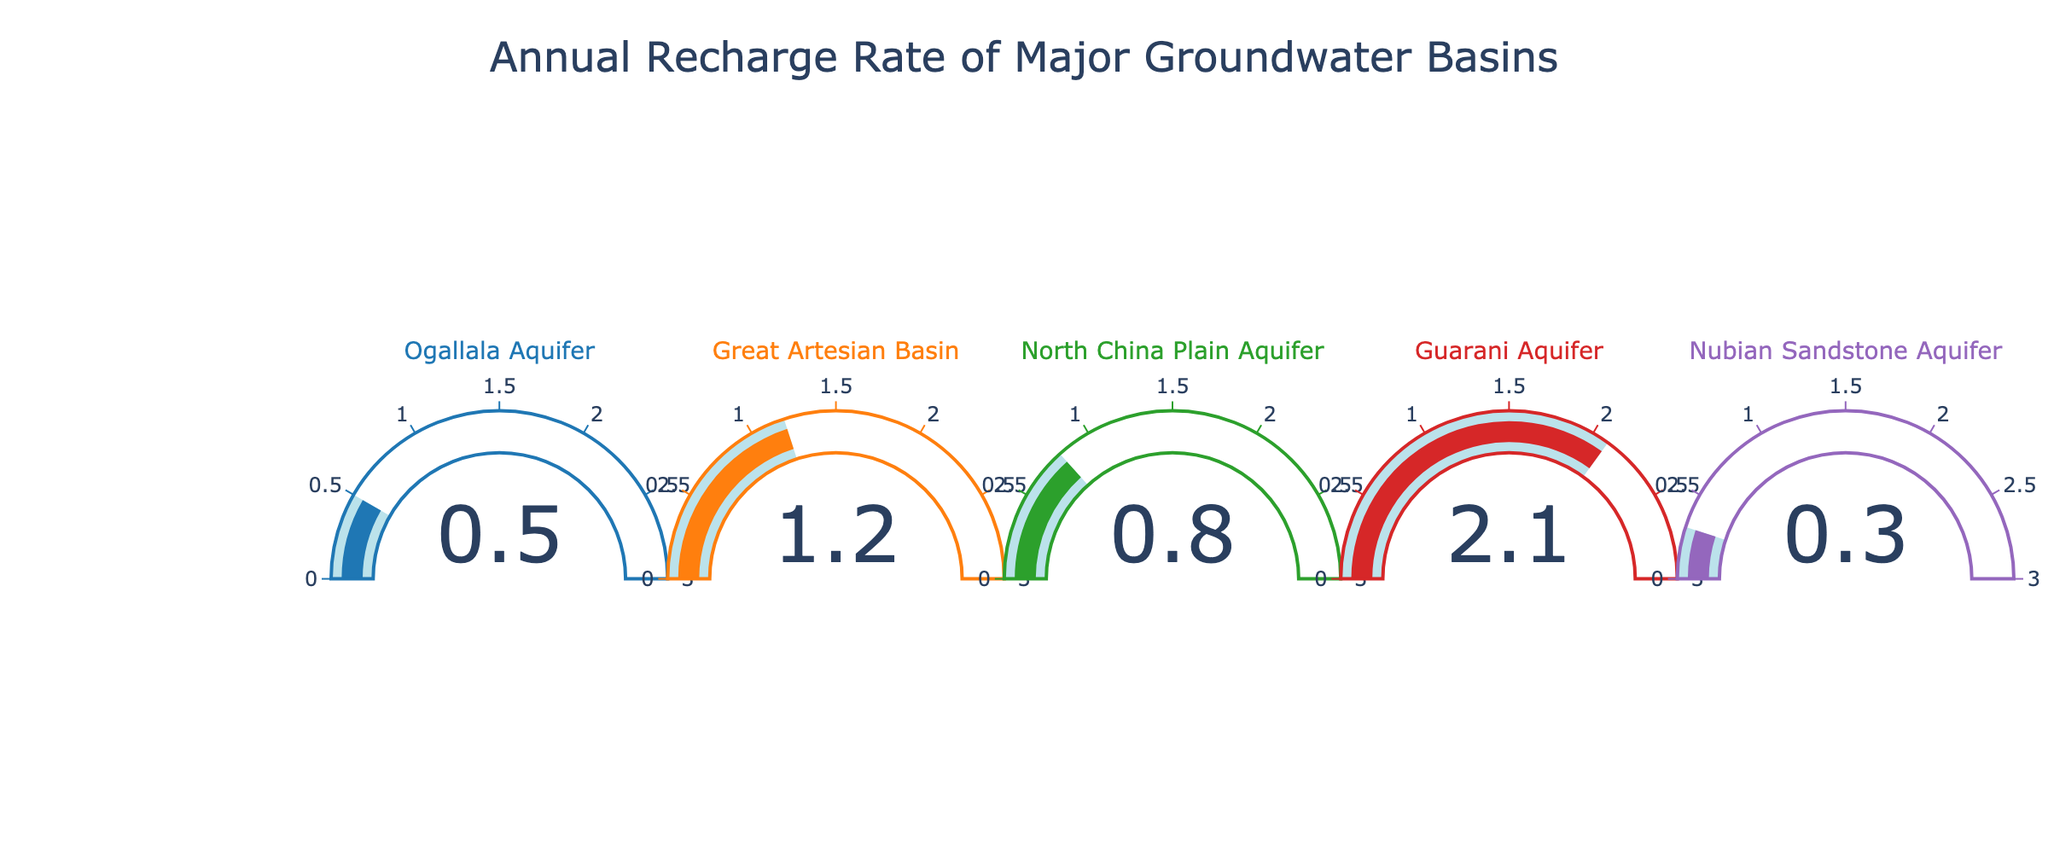what is the title of the figure? The title of the figure is usually presented at the top of the chart. By looking at the top center, we can see the title.
Answer: Annual Recharge Rate of Major Groundwater Basins How many groundwater basins are represented in the chart? By counting the number of individual gauges on the chart, each representing a basin, you can determine the total number.
Answer: 5 Which groundwater basin has the highest annual recharge rate? Observe the value indicated by each gauge. The one with the highest number represents the highest recharge rate.
Answer: Guarani Aquifer What is the range of values on the gauge axis? The gauge axis range is often indicated along the semi-circle of the gauge. One can observe the minimum and maximum values noted on the axis.
Answer: 0 to 3 What is the average annual recharge rate of all the basins? Sum the recharge rates of all basins (0.5 + 1.2 + 0.8 + 2.1 + 0.3) and divide by the number of basins (5). The calculation will give the average value.
Answer: 0.98 Which basin has the lowest annual recharge rate? Look at the values displayed in each gauge. The one with the smallest number will be the lowest.
Answer: Nubian Sandstone Aquifer What is the difference in the annual recharge rate between the Guarani Aquifer and the Great Artesian Basin? Subtract the annual recharge rate of the Great Artesian Basin (1.2) from that of the Guarani Aquifer (2.1).
Answer: 0.9 What is the combined annual recharge rate of the Ogallala Aquifer and the North China Plain Aquifer? Add the individual annual recharge rates of the Ogallala Aquifer (0.5) and the North China Plain Aquifer (0.8).
Answer: 1.3 Which color represents the Great Artesian Basin? The color indicated in the gauge decoration and title for the Great Artesian Basin corresponds to the associated value.
Answer: Orange (usually, but the exact color would be derived from the chart specifics) Is there any basin with an annual recharge rate above 2? By checking each gauge value, determine if any gauge shows a value greater than 2. In this case, verify the specific value shown for the basins.
Answer: Yes (Guarani Aquifer) 